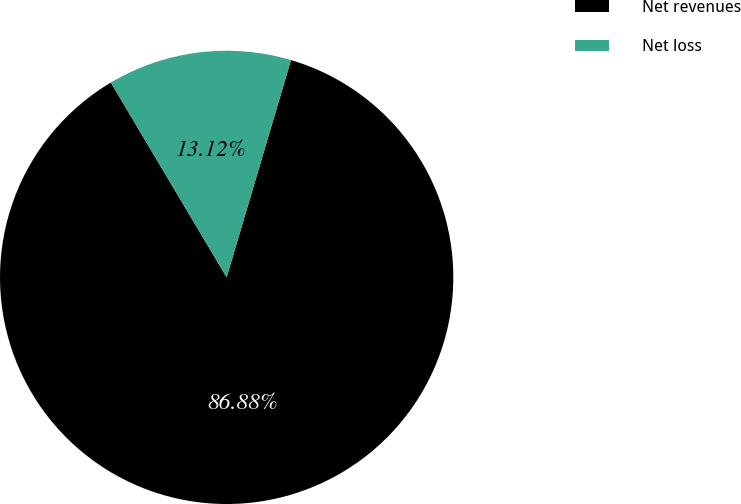Convert chart to OTSL. <chart><loc_0><loc_0><loc_500><loc_500><pie_chart><fcel>Net revenues<fcel>Net loss<nl><fcel>86.88%<fcel>13.12%<nl></chart> 